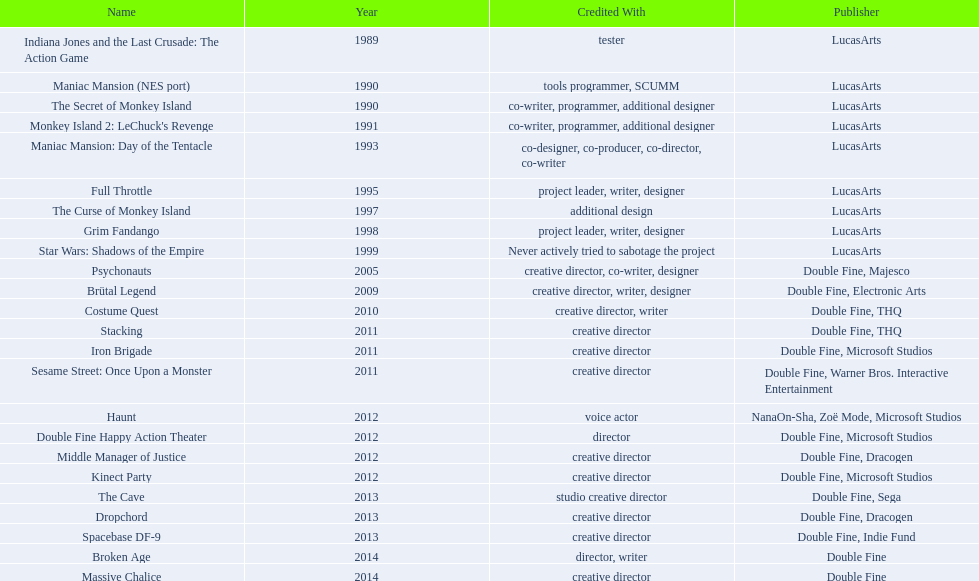Which game is credited with a creative director? Creative director, co-writer, designer, creative director, writer, designer, creative director, writer, creative director, creative director, creative director, creative director, creative director, creative director, creative director, creative director. Of these games, which also has warner bros. interactive listed as creative director? Sesame Street: Once Upon a Monster. 